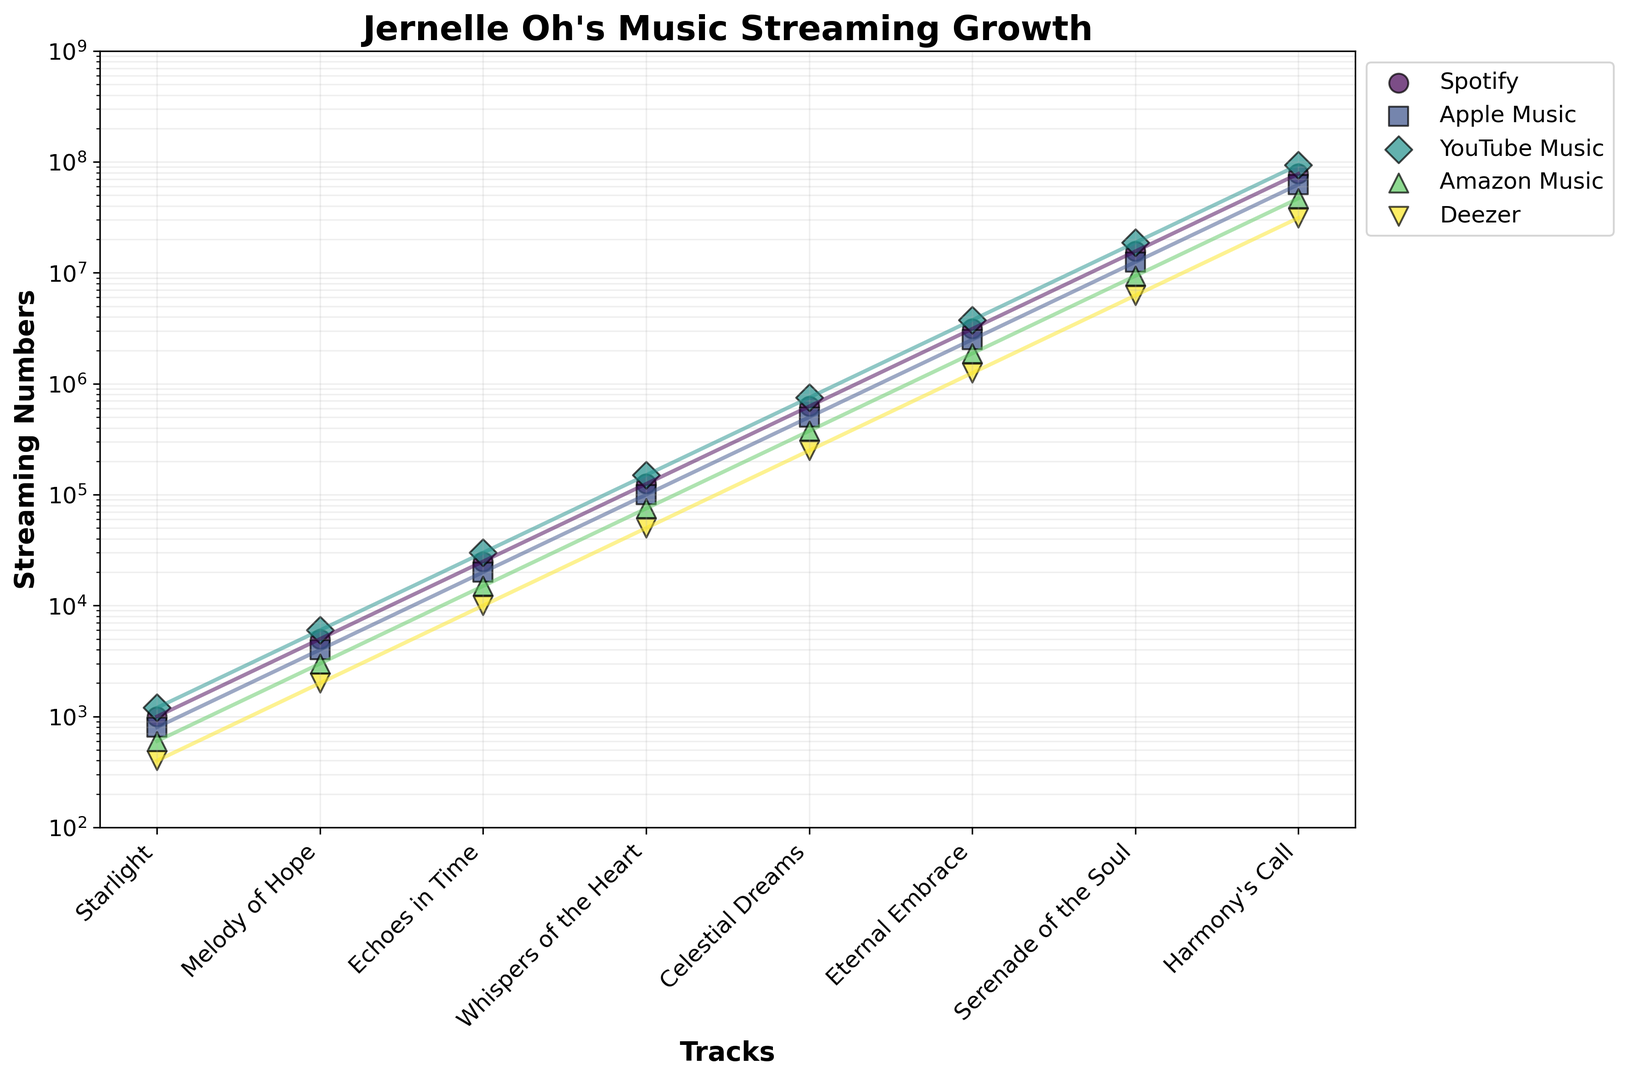Which track has the highest overall streaming numbers across all platforms? "Harmony's Call" has the highest numbers across all platforms as it consistently appears at the top position in the scatter plot on the y-axis (log scale).
Answer: "Harmony's Call" What is the average streaming number for "Celestial Dreams" across all platforms? Add the streaming numbers for "Celestial Dreams" on each platform (Spotify: 625,000, Apple Music: 500,000, YouTube Music: 750,000, Amazon Music: 375,000, Deezer: 250,000) and divide by the number of platforms (5). So the calculation is (625,000 + 500,000 + 750,000 + 375,000 + 250,000) / 5 = 2,500,000 / 5 = 500,000.
Answer: 500,000 Which platform has the highest streaming numbers for "Starlight" and what is that number? On examining the scatter plot, the point corresponding to "Starlight" on YouTube Music is the highest among the platforms. The number is 1,200.
Answer: YouTube Music, 1,200 Which track has the greatest difference in streaming numbers between Spotify and Deezer? Calculate the difference for each track (Spotify - Deezer) and find the maximum. The differences are: 
"Starlight": 600, "Melody of Hope": 3000, 
"Echoes in Time": 15000, "Whispers of the Heart": 75000, "Celestial Dreams": 375000, 
"Eternal Embrace": 1875000, "Serenade of the Soul": 9375000, 
"Harmony's Call": 46875000. The greatest difference is for "Harmony's Call".
Answer: "Harmony's Call" Which track has the smallest streaming numbers on Amazon Music? By checking the scatter points at the lowest position on the y-axis (log scale) for Amazon Music, "Starlight" has the fewest streams with 600.
Answer: "Starlight", 600 What is the total streaming number for "Echoes in Time" across Spotify and Apple Music? Add the streaming numbers for "Echoes in Time" on Spotify (25,000) and Apple Music (20,000): 25,000 + 20,000 = 45,000.
Answer: 45,000 How do the streaming numbers of "Eternal Embrace" on Spotify compare to its numbers on YouTube Music? "Eternal Embrace" on Spotify has 3,125,000 streams, while on YouTube Music it has 3,750,000 streams. Comparing these two values, YouTube Music has higher numbers.
Answer: YouTube Music has higher numbers For which track is the streaming number on Deezer exactly one-quarter of the number on Spotify? Check the tracks and their respective ratios: "Starlight" (400/1000 = 0.4), "Melody of Hope" (2000/5000 = 0.4), "Echoes in Time" (10000/25000 = 0.4), "Whispers of the Heart" (50000/125000 = 0.4), "Celestial Dreams" (250000/625000 = 0.4), "Eternal Embrace" (1250000/3125000 = 0.4), "Serenade of the Soul" (6250000/15625000 = 0.4), "Harmony’s Call" (31250000/78125000 = 0.4). None of the tracks have a ratio of exactly 1/4, but all have ratios around 0.4.
Answer: None (all have 0.4 ratio) How does the trend of streaming numbers for each platform change as we go from "Starlight" to "Harmony's Call"? Observe the scatter plot line for each platform. Each platform's numbers consistently increase from "Starlight" to "Harmony's Call", indicating a positive growth trend on a logscale for all tracks.
Answer: Consistently increases 